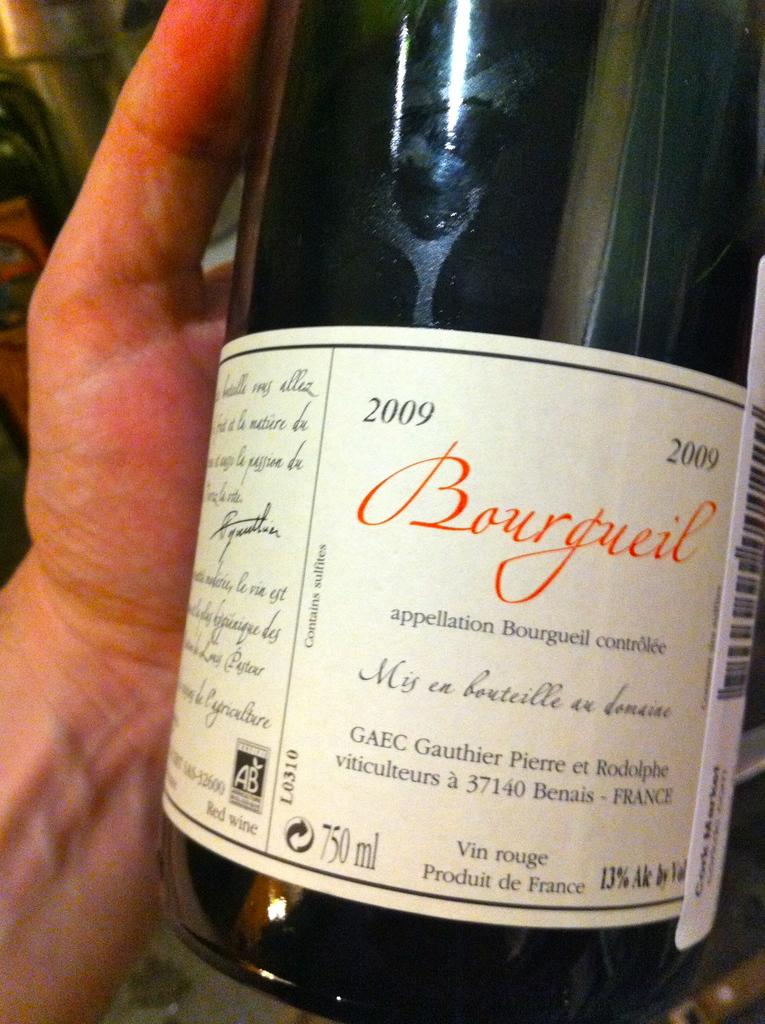<image>
Offer a succinct explanation of the picture presented. a bottle lab for bourgueil 2009 wine product of france 